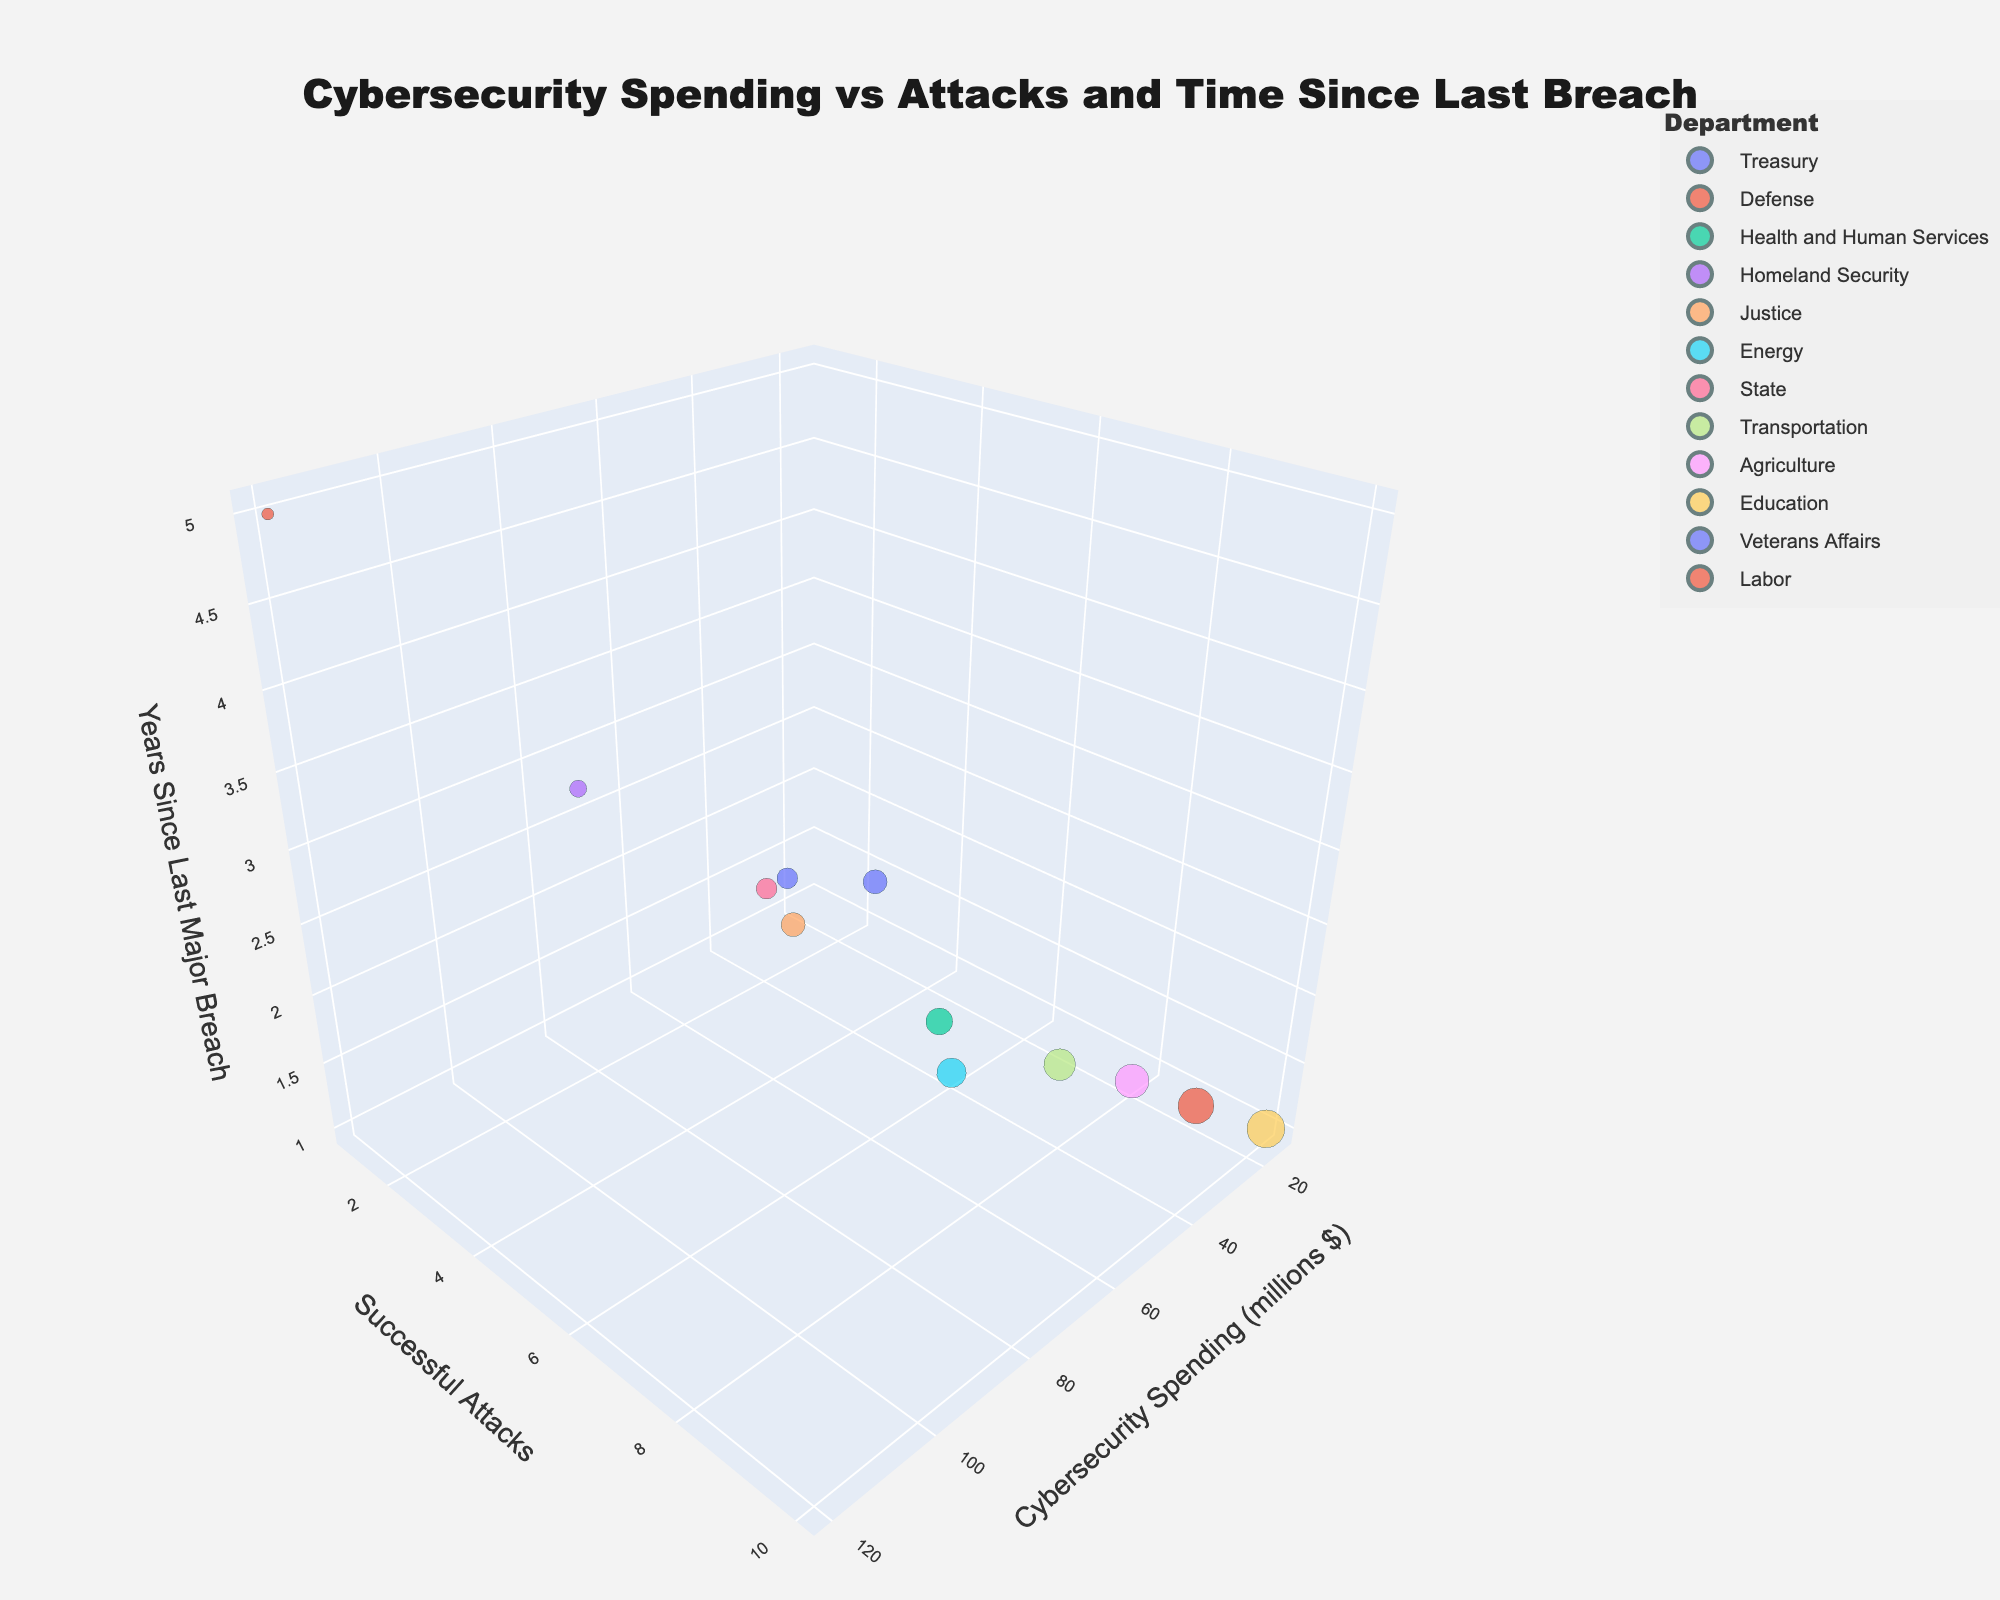Which department has the highest cybersecurity spending? The figure shows bubbles along the x-axis representing cybersecurity spending. By locating the highest value, we see that the Defense department has the highest spending at $120 million.
Answer: Defense Which department has the most successful attacks? The y-axis represents the number of successful attacks. The bubble highest on the y-axis is for the Education department, indicating 10 successful attacks.
Answer: Education How many years since the last major breach for the Defense department? The z-axis represents years since the last major breach. Finding the bubble for the Defense department and checking its position on the z-axis reveals it has been 5 years since the last major breach.
Answer: 5 years Which department has both high cybersecurity spending and few successful attacks? To find this, look for bubbles located high on the x-axis and low on the y-axis simultaneously. The Defense department has high spending ($120 million) and only 1 successful attack.
Answer: Defense Which department had a major breach most recently? The bubble closest to the z-axis (at 1 year since the last breach) represents the most recent major breach. Departments such as Health and Human Services, Energy, Transportation, Agriculture, Education, and Labor all fit this description.
Answer: Health and Human Services, Energy, Transportation, Agriculture, Education, Labor What is the difference in successful attacks between the Treasury and Agriculture departments? The Treasury department has 3 successful attacks, and Agriculture has 8 successful attacks. The difference is 8 - 3 = 5.
Answer: 5 What's the total cybersecurity spending of departments with less than 5 successful attacks? Identify the departments with less than 5 successful attacks: Treasury ($45M), Defense ($120M), Homeland Security ($80M), and State ($50M). Summing their spending: 45 + 120 + 80 + 50 = $295 million.
Answer: $295 million How many departments have more than 3 years since their last major breach? Identify bubbles above the 3-year mark on the z-axis. Only the Defense department meets this criterion. Therefore, the count is one.
Answer: 1 Which department has similar cybersecurity spending to Homeland Security? Look for departments close to Homeland Security's cybersecurity spending ($80M) on the x-axis. The State department, which spends $50M, is the closest.
Answer: State 